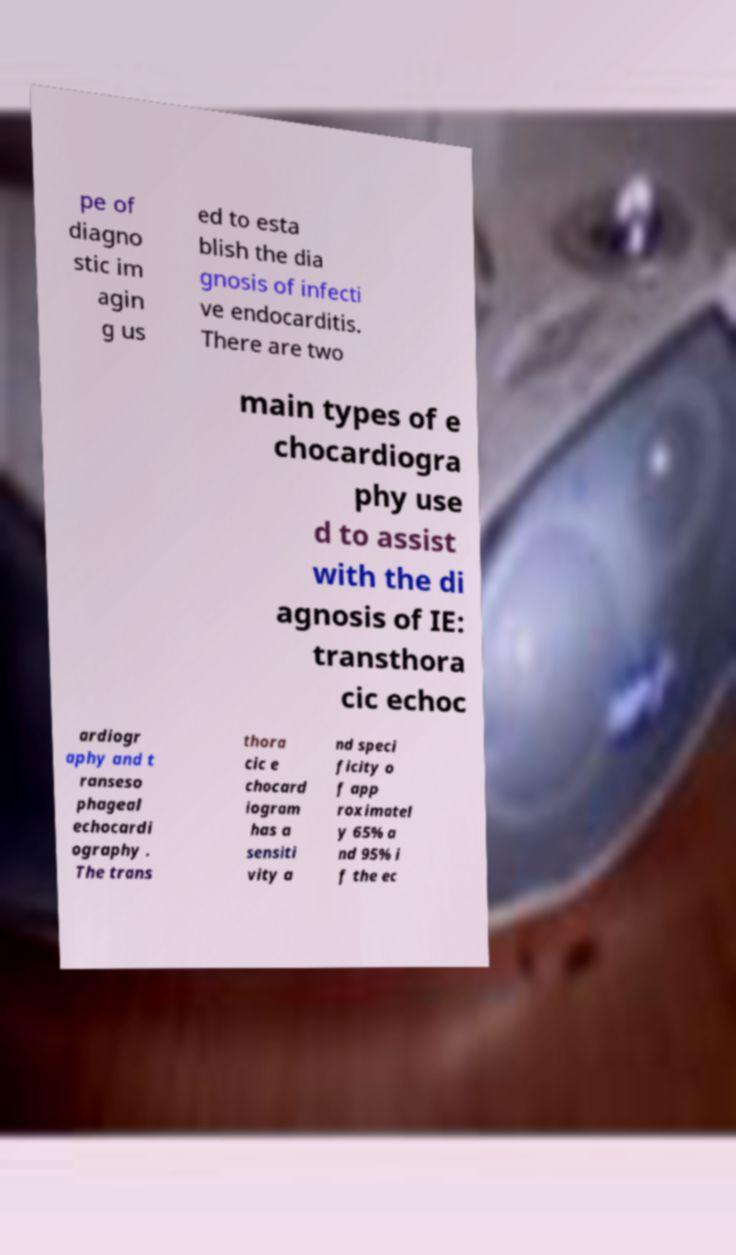Could you assist in decoding the text presented in this image and type it out clearly? pe of diagno stic im agin g us ed to esta blish the dia gnosis of infecti ve endocarditis. There are two main types of e chocardiogra phy use d to assist with the di agnosis of IE: transthora cic echoc ardiogr aphy and t ranseso phageal echocardi ography . The trans thora cic e chocard iogram has a sensiti vity a nd speci ficity o f app roximatel y 65% a nd 95% i f the ec 